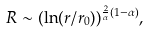Convert formula to latex. <formula><loc_0><loc_0><loc_500><loc_500>R \sim ( \ln ( r / r _ { 0 } ) ) ^ { \frac { 2 } { \alpha } ( 1 - \alpha ) } ,</formula> 